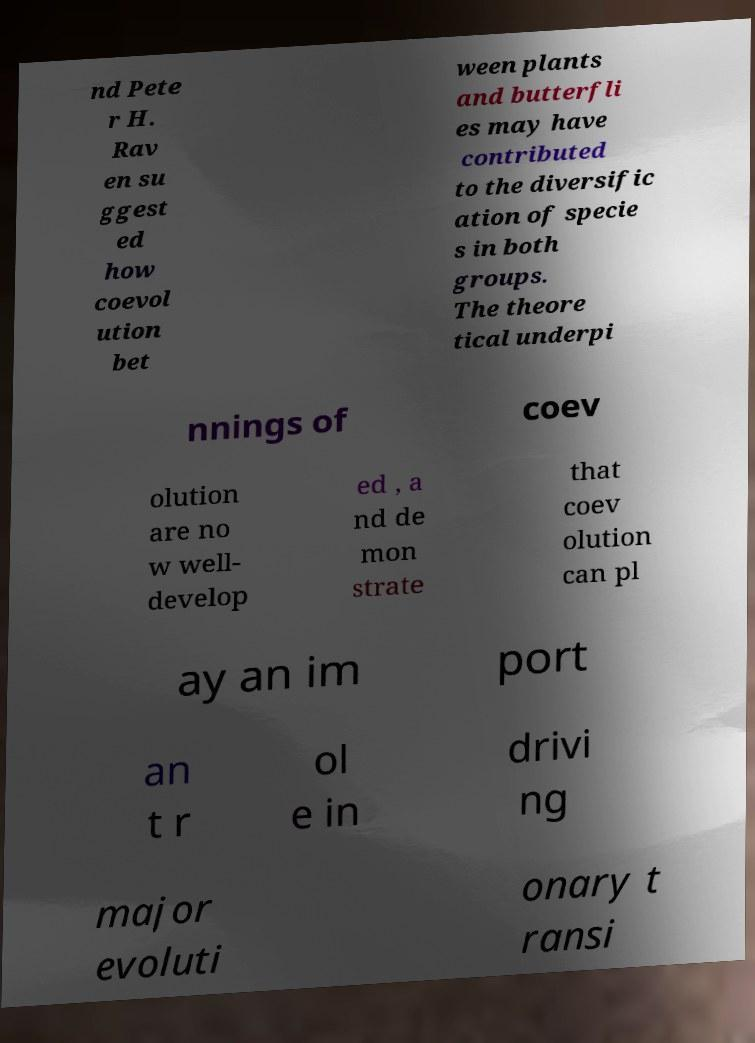Could you extract and type out the text from this image? nd Pete r H. Rav en su ggest ed how coevol ution bet ween plants and butterfli es may have contributed to the diversific ation of specie s in both groups. The theore tical underpi nnings of coev olution are no w well- develop ed , a nd de mon strate that coev olution can pl ay an im port an t r ol e in drivi ng major evoluti onary t ransi 